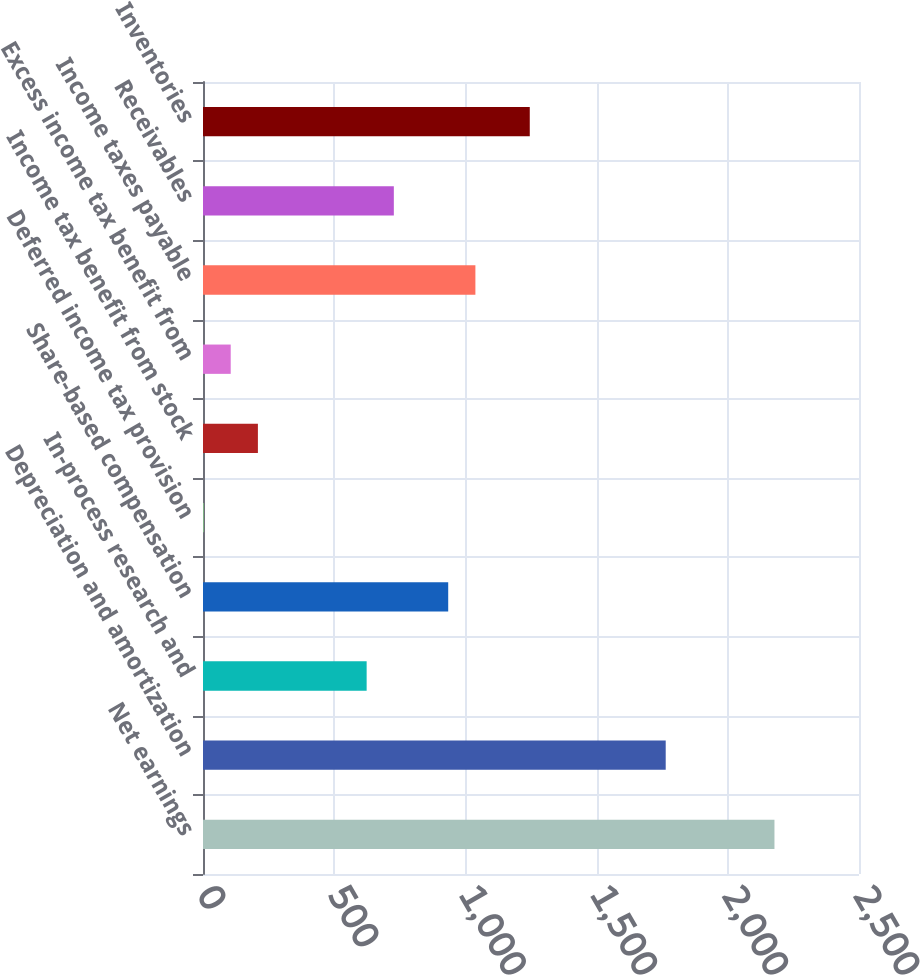<chart> <loc_0><loc_0><loc_500><loc_500><bar_chart><fcel>Net earnings<fcel>Depreciation and amortization<fcel>In-process research and<fcel>Share-based compensation<fcel>Deferred income tax provision<fcel>Income tax benefit from stock<fcel>Excess income tax benefit from<fcel>Income taxes payable<fcel>Receivables<fcel>Inventories<nl><fcel>2177.81<fcel>1763.37<fcel>623.66<fcel>934.49<fcel>2<fcel>209.22<fcel>105.61<fcel>1038.1<fcel>727.27<fcel>1245.32<nl></chart> 